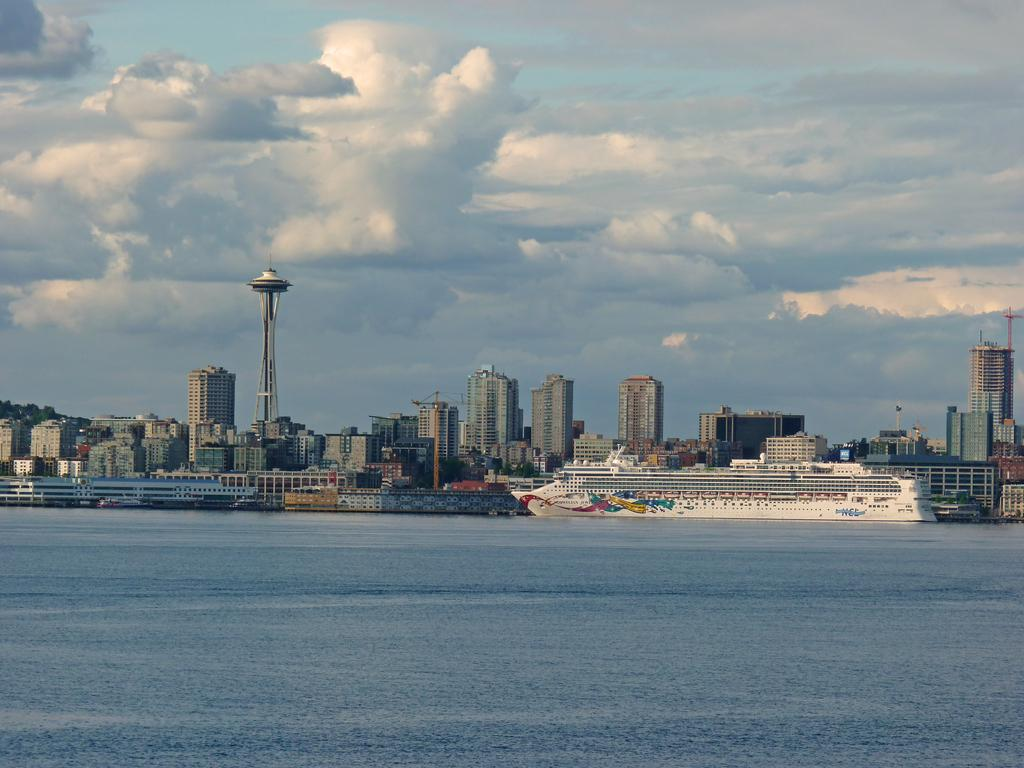What is the main subject of the image? The main subject of the image is a ship in the water. What can be seen in the background of the image? There are buildings and a tower in the background of the image. What is visible at the top of the image? The sky is visible at the top of the image, and there are clouds in the sky. What is present at the bottom of the image? Water is visible at the bottom of the image. How many bricks are used to build the bird in the image? There is no bird present in the image, and therefore no bricks are used to build it. 